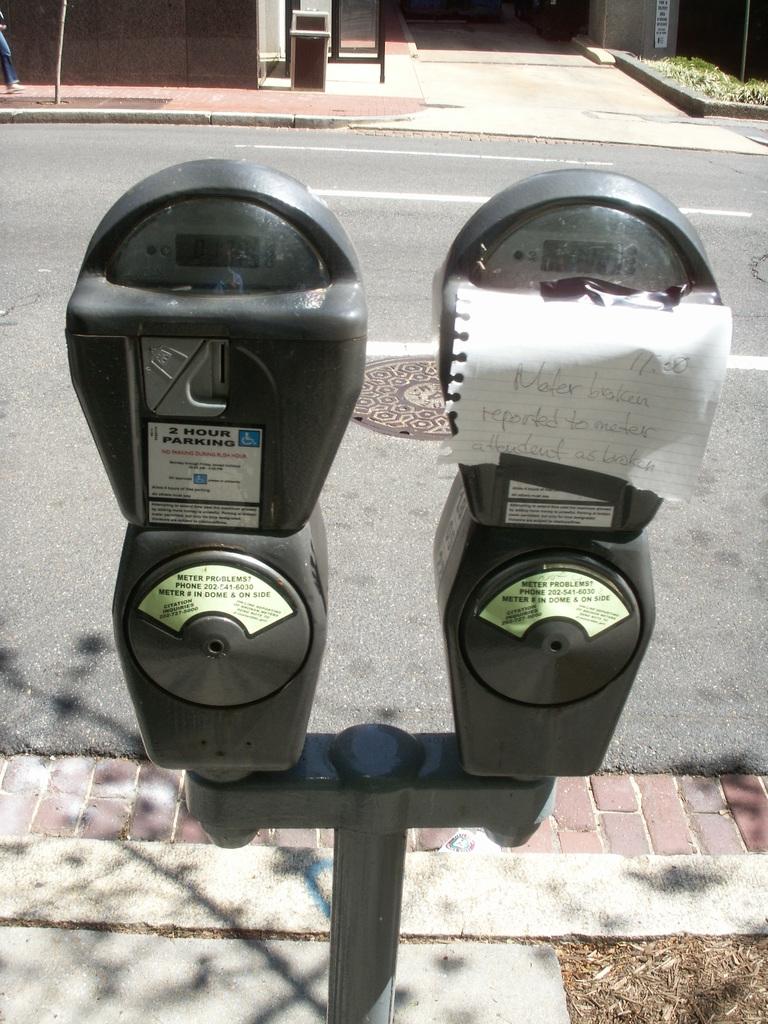What does the left meter say?
Keep it short and to the point. 2 hour parking. 